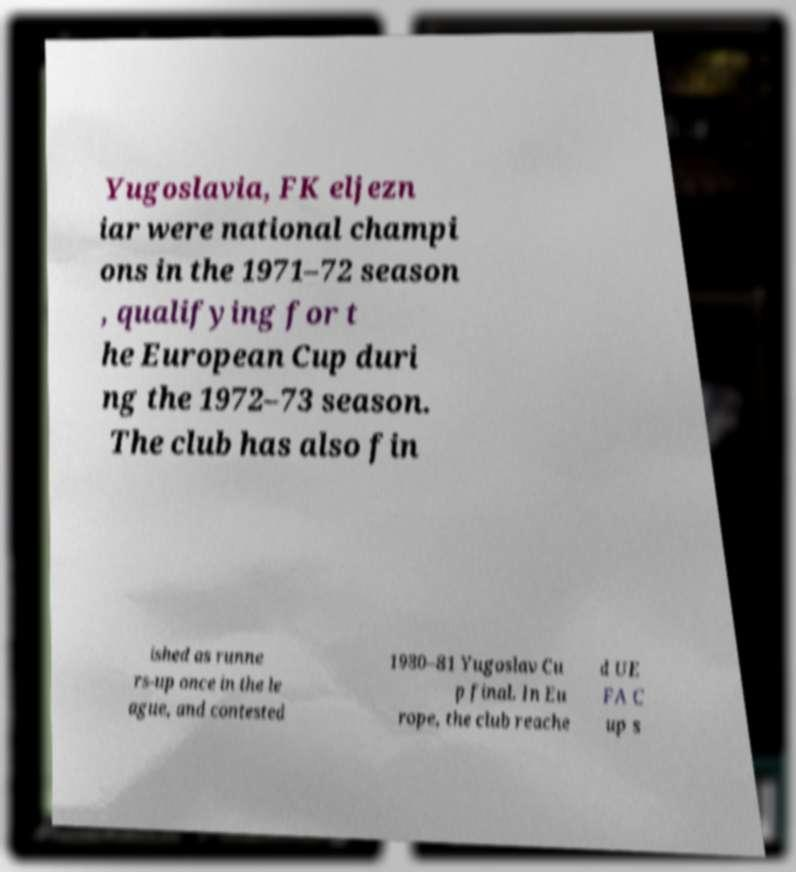Please identify and transcribe the text found in this image. Yugoslavia, FK eljezn iar were national champi ons in the 1971–72 season , qualifying for t he European Cup duri ng the 1972–73 season. The club has also fin ished as runne rs-up once in the le ague, and contested 1980–81 Yugoslav Cu p final. In Eu rope, the club reache d UE FA C up s 